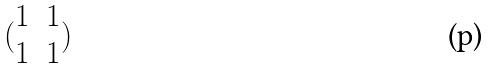<formula> <loc_0><loc_0><loc_500><loc_500>( \begin{matrix} 1 & 1 \\ 1 & 1 \end{matrix} )</formula> 